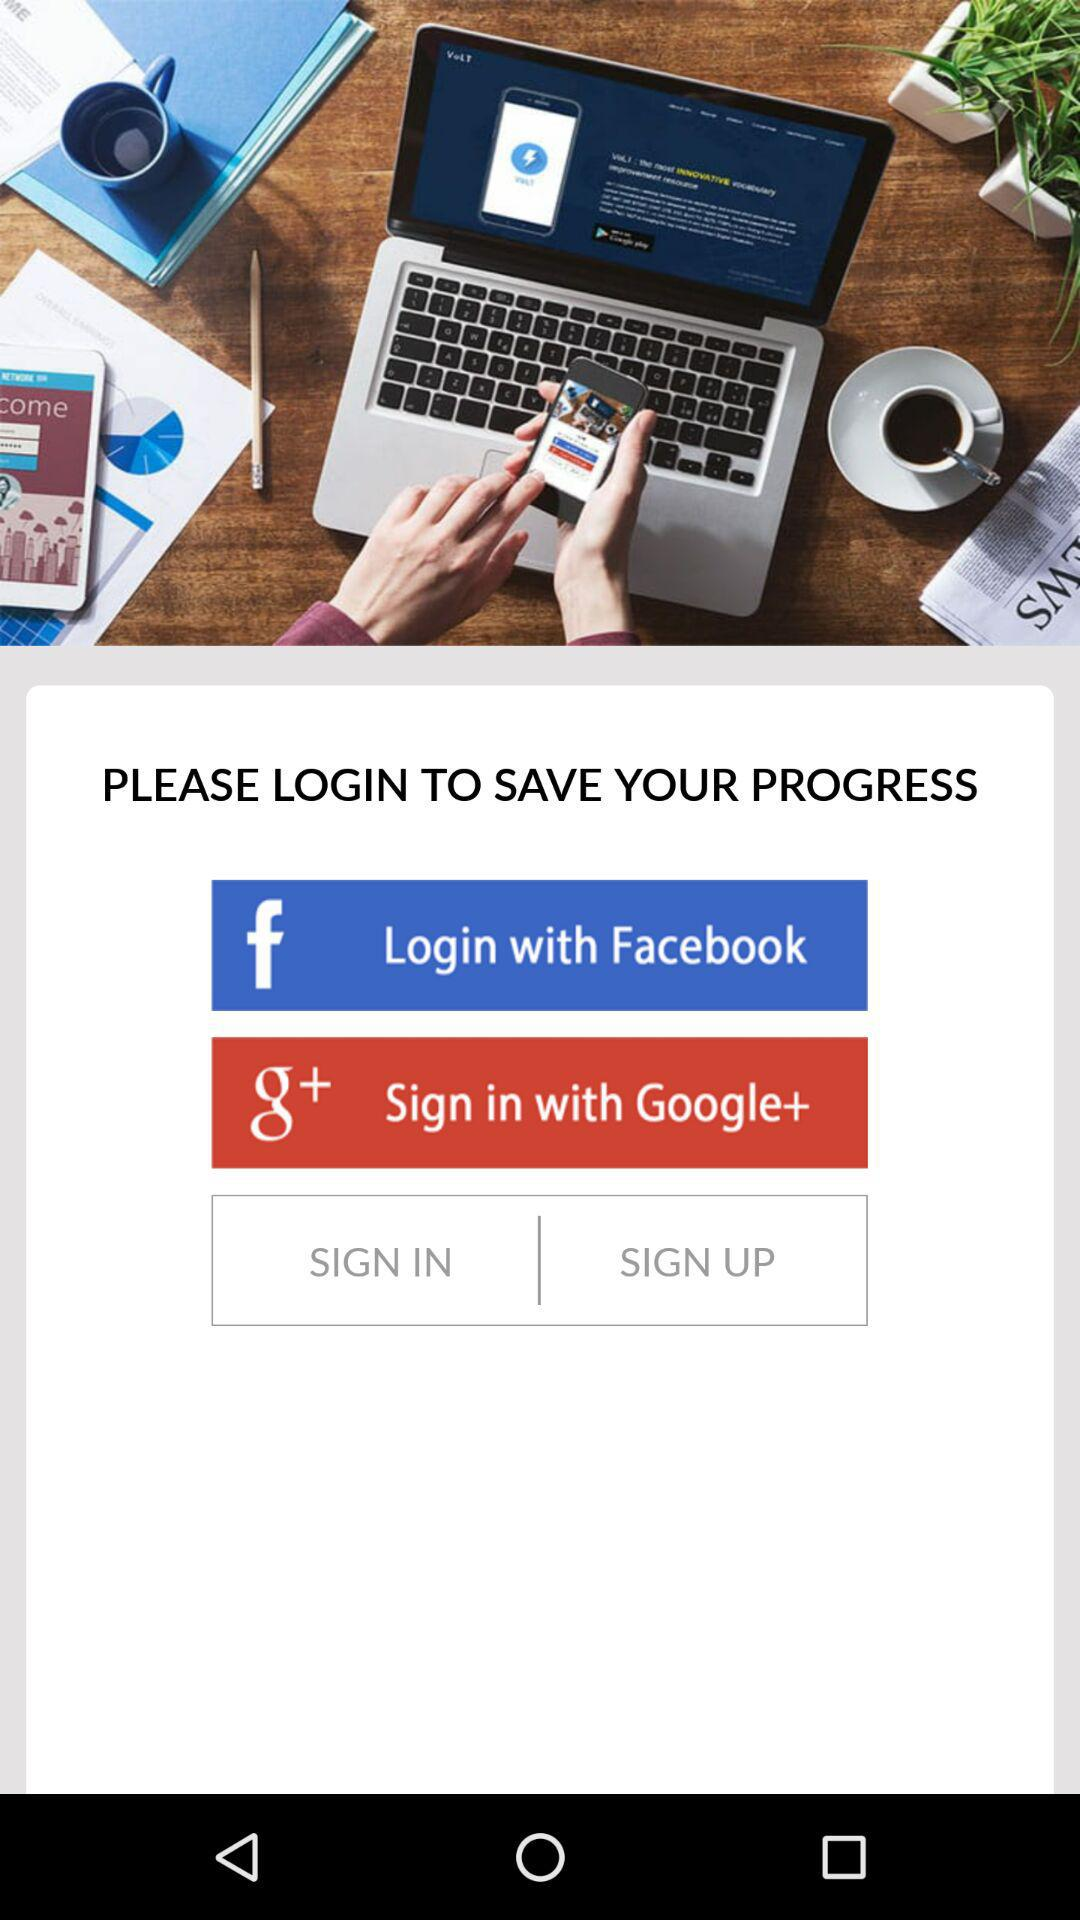How many login options are there?
Answer the question using a single word or phrase. 2 